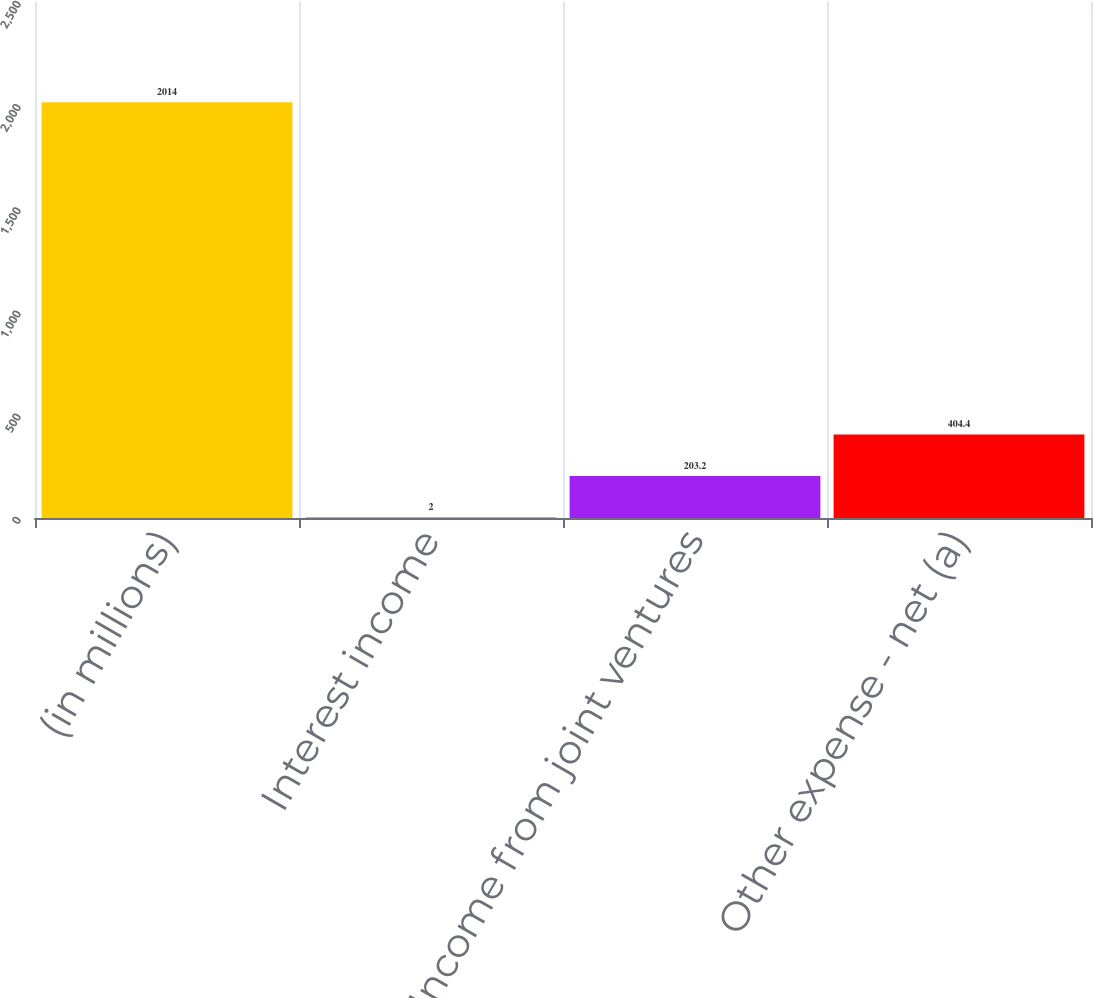<chart> <loc_0><loc_0><loc_500><loc_500><bar_chart><fcel>(in millions)<fcel>Interest income<fcel>Income from joint ventures<fcel>Other expense - net (a)<nl><fcel>2014<fcel>2<fcel>203.2<fcel>404.4<nl></chart> 